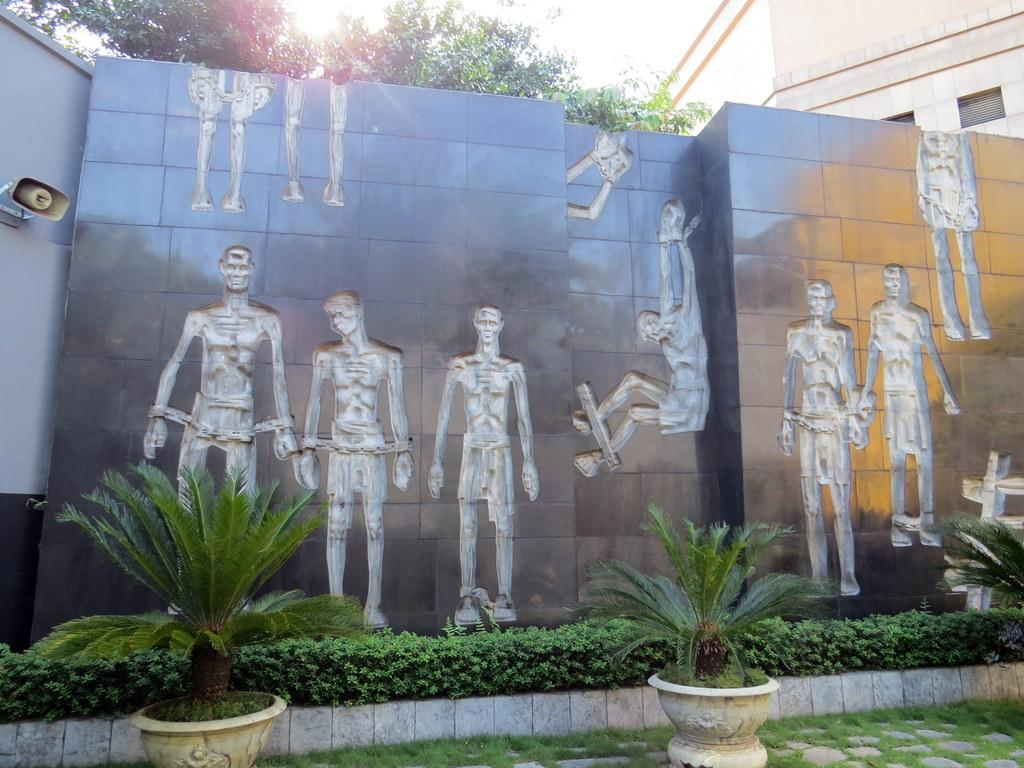What type of living organisms can be seen in the image? Plants and a tree are visible in the image. What type of structure is present in the image? There is a building in the image. What object is used for amplifying sound in the image? There is a speaker in the image. What type of artwork is present on a wall in the image? There is an art piece on a wall in the image. What decision was made by the tree in the image? Trees do not make decisions, as they are living organisms and not capable of making conscious choices. 